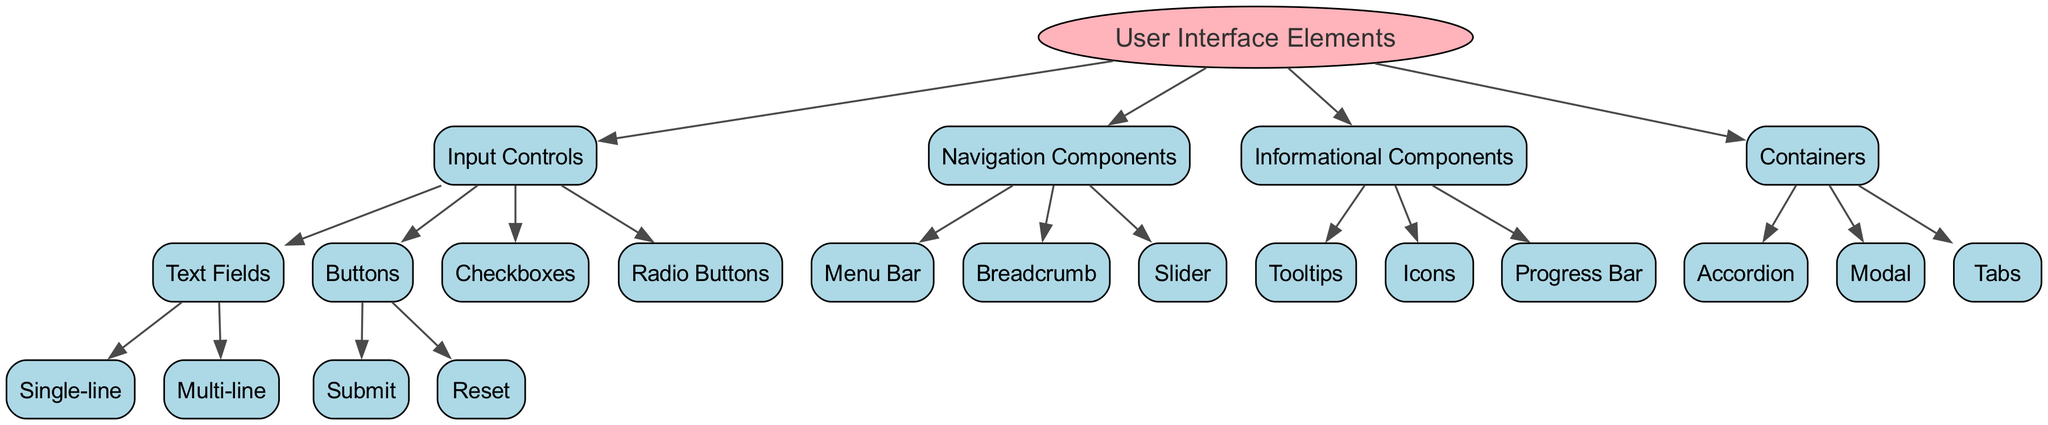What is the root node of the diagram? The root node, as indicated at the top of the diagram, is "User Interface Elements."
Answer: User Interface Elements How many input control types are present? By examining the "Input Controls" section, there are four types listed: Text Fields, Buttons, Checkboxes, and Radio Buttons.
Answer: 4 Which child node comes after "Navigation Components"? After "Navigation Components," the next child node is "Informational Components," as per the sequential structure shown in the diagram.
Answer: Informational Components What is the total number of components under "Containers"? Under "Containers," there are three components listed: Accordion, Modal, and Tabs, thus totaling three.
Answer: 3 Identify one type of button under "Input Controls." The diagram lists "Submit" and "Reset" as types of buttons under "Input Controls." Choosing either one satisfies the question.
Answer: Submit Which type of user interface element has multi-line capability? The "Text Fields" section under "Input Controls" explicitly lists "Multi-line" as a type, indicating it has the capability in question.
Answer: Multi-line How many edges connect the "Input Controls" node to its children? The "Input Controls" node connects to four children (Text Fields, Buttons, Checkboxes, and Radio Buttons), resulting in four edges.
Answer: 4 What category contains "Tooltips"? "Tooltips" is found under the "Informational Components" category as identified in the structure of the diagram.
Answer: Informational Components Which child node of "User Interface Elements" has the least number of elements shown? The "Navigation Components" contains three elements (Menu Bar, Breadcrumb, Slider), which is the least compared to others, like "Input Controls" or "Informational Components" which have more.
Answer: Navigation Components 